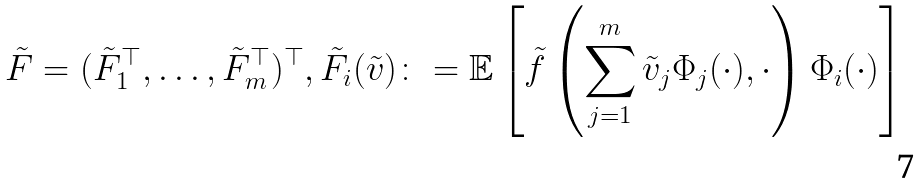<formula> <loc_0><loc_0><loc_500><loc_500>\tilde { F } = ( \tilde { F } _ { 1 } ^ { \top } , \dots , \tilde { F } _ { m } ^ { \top } ) ^ { \top } , \tilde { F } _ { i } ( \tilde { v } ) \colon = \mathbb { E } \left [ \tilde { f } \left ( \sum _ { j = 1 } ^ { m } \tilde { v } _ { j } \Phi _ { j } ( \cdot ) , \cdot \right ) \Phi _ { i } ( \cdot ) \right ]</formula> 